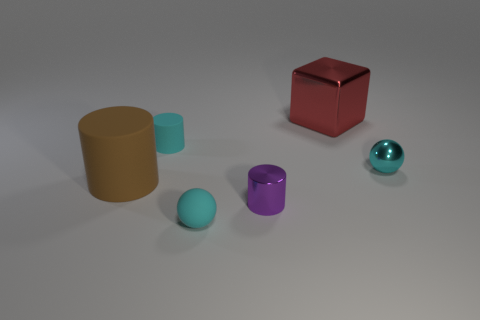There is a tiny cylinder that is the same color as the tiny metal ball; what is its material?
Provide a succinct answer. Rubber. There is a red thing; is its size the same as the cylinder behind the large cylinder?
Provide a short and direct response. No. Is the number of big blue metallic cubes greater than the number of red shiny blocks?
Provide a short and direct response. No. Is the cyan sphere that is behind the large rubber thing made of the same material as the small sphere that is to the left of the purple cylinder?
Give a very brief answer. No. What material is the brown object?
Provide a short and direct response. Rubber. Is the number of large red things to the right of the cyan metallic sphere greater than the number of green metallic spheres?
Your answer should be compact. No. What number of balls are in front of the small cyan sphere right of the metal thing in front of the brown object?
Provide a short and direct response. 1. The cylinder that is both on the left side of the tiny metallic cylinder and on the right side of the brown rubber object is made of what material?
Ensure brevity in your answer.  Rubber. What is the color of the big matte thing?
Your answer should be very brief. Brown. Is the number of cyan objects that are in front of the tiny purple thing greater than the number of tiny cyan balls that are left of the brown cylinder?
Offer a very short reply. Yes. 